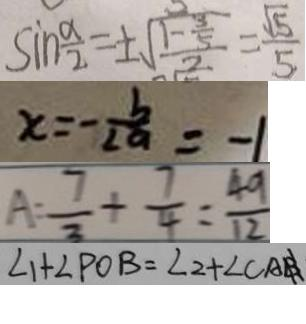<formula> <loc_0><loc_0><loc_500><loc_500>\sin \frac { \alpha } { 2 } = \pm \sqrt { \frac { 1 - \frac { 3 } { 5 } } { 2 } } = \frac { \sqrt { 5 } } { 5 } 
 x = - \frac { b } { 2 a } = - 1 
 A = \frac { 7 } { 3 } + \frac { 7 } { 4 } = \frac { 4 9 } { 1 2 } 
 \angle 1 + \angle P O B = \angle 2 + \angle C A B</formula> 